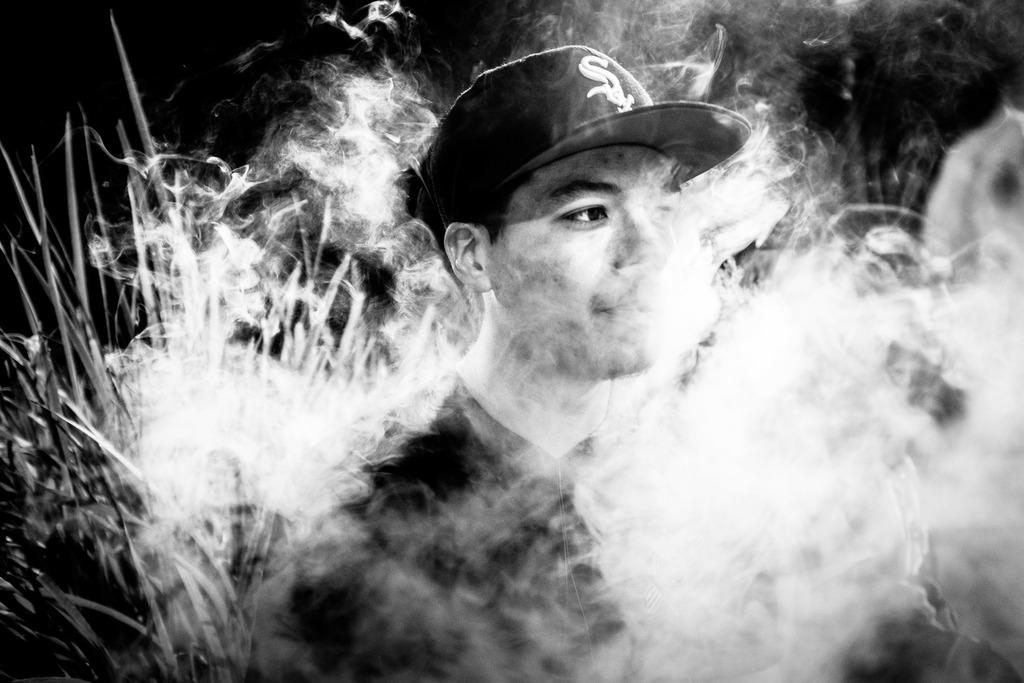Who is present in the image? There is a man in the image. What is the man wearing on his head? The man is wearing a cap. What type of clothing is the man wearing on his upper body? The man is wearing a t-shirt. What can be seen in the image that is not a part of the man or the plants? There is smoke visible in the image. Where are the plants located in the image? The plants are on the left side of the image. What is the condition of the top left corner of the image? The top left corner of the image appears to be dark. What type of cloth is the man using to wipe the stove in the image? There is no stove present in the image, and the man is not using any cloth to wipe anything. 